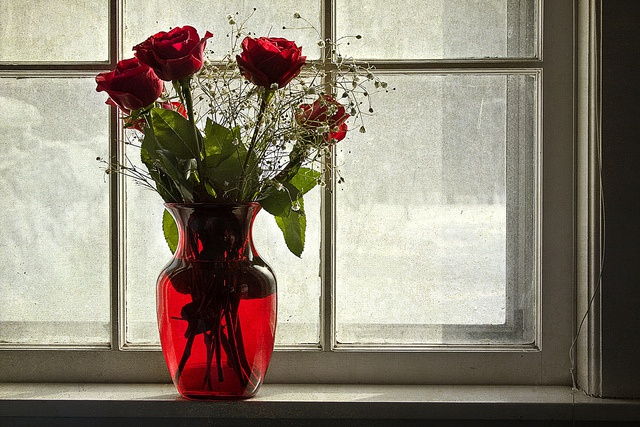Describe the objects in this image and their specific colors. I can see potted plant in darkgray, black, ivory, maroon, and darkgreen tones and vase in darkgray, black, red, maroon, and brown tones in this image. 